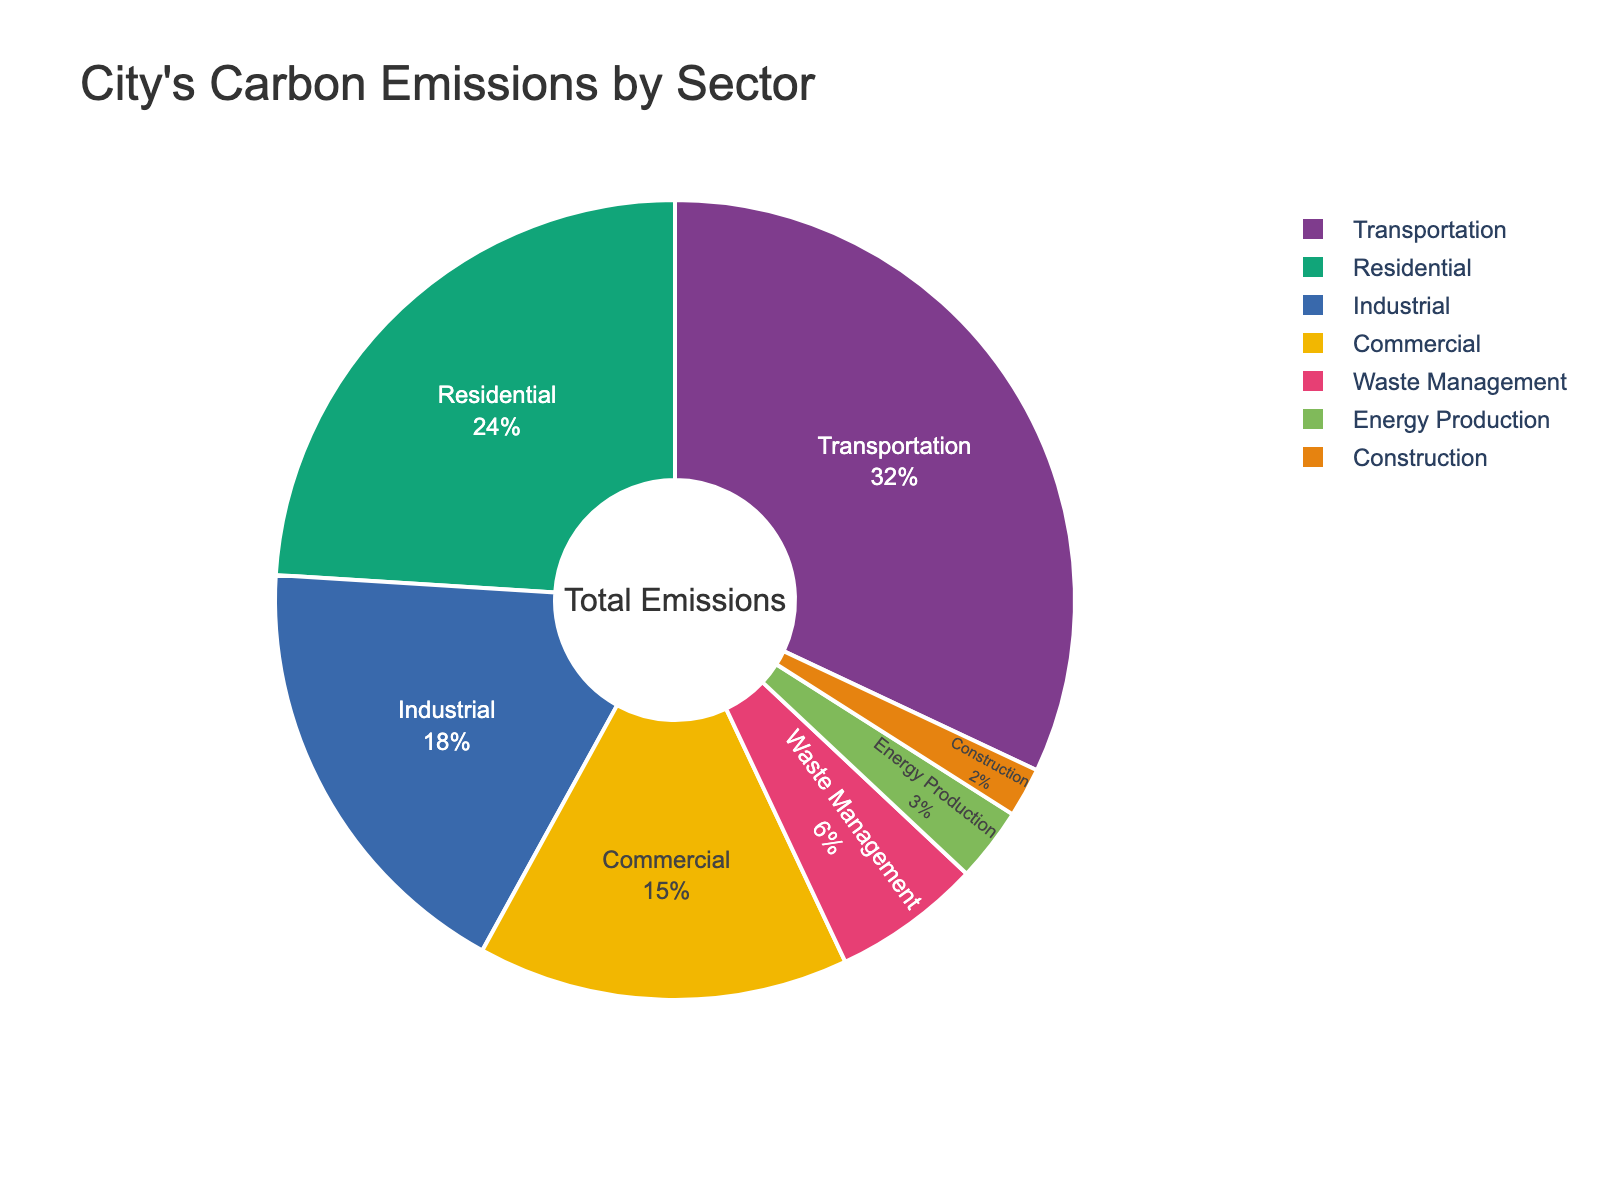Which sector contributes the highest to carbon emissions? The sector with the largest slice in the pie chart represents the highest contributor. Transportation has the largest slice.
Answer: Transportation Which sector has the lowest contribution to carbon emissions? The sector with the smallest slice in the pie chart represents the lowest contributor. Construction has the smallest slice.
Answer: Construction How much more carbon emissions does the Transportation sector produce compared to the Construction sector? The percentage for Transportation is 32%, and for Construction, it’s 2%. Subtracting 2 from 32 gives the difference.
Answer: 30% What is the combined percentage of carbon emissions for Residential and Industrial sectors? Add the percentages for Residential (24%) and Industrial (18%). 24 + 18 = 42
Answer: 42% Is the percentage of carbon emissions from Waste Management greater than the percentage from Energy Production? Compare the slices for Waste Management (6%) and Energy Production (3%). 6% is greater than 3%.
Answer: Yes Which sector has twice the carbon emissions of Energy Production? Energy Production accounts for 3%. Find a sector that has approximately 6%, which is Waste Management.
Answer: Waste Management What is the percentage difference between Commercial and Industrial sectors? Subtract the percentage of the Industrial sector (18%) from the Commercial sector (15%). 18 - 15 = 3
Answer: 3% If we combine the emissions from the Transportation and Residential sectors, what fraction of the total pie does this represent? Transportation is 32% and Residential is 24%. Sum them to get 56%.
Answer: 56% Are the combined emissions of the Waste Management and Construction sectors greater than the emissions from the Commercial sector? Add Waste Management (6%) and Construction (2%). Compare this to Commercial (15%). 6 + 2 = 8, which is less than 15.
Answer: No 